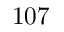Convert formula to latex. <formula><loc_0><loc_0><loc_500><loc_500>1 0 7</formula> 